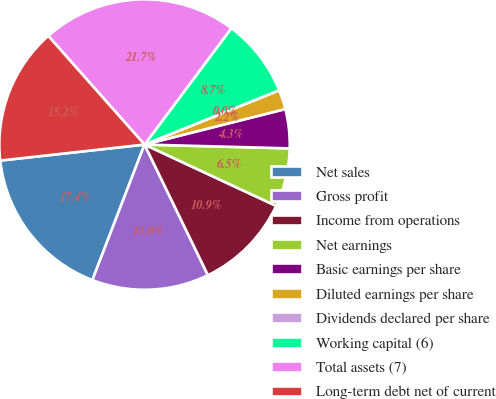<chart> <loc_0><loc_0><loc_500><loc_500><pie_chart><fcel>Net sales<fcel>Gross profit<fcel>Income from operations<fcel>Net earnings<fcel>Basic earnings per share<fcel>Diluted earnings per share<fcel>Dividends declared per share<fcel>Working capital (6)<fcel>Total assets (7)<fcel>Long-term debt net of current<nl><fcel>17.39%<fcel>13.04%<fcel>10.87%<fcel>6.52%<fcel>4.35%<fcel>2.17%<fcel>0.0%<fcel>8.7%<fcel>21.74%<fcel>15.22%<nl></chart> 